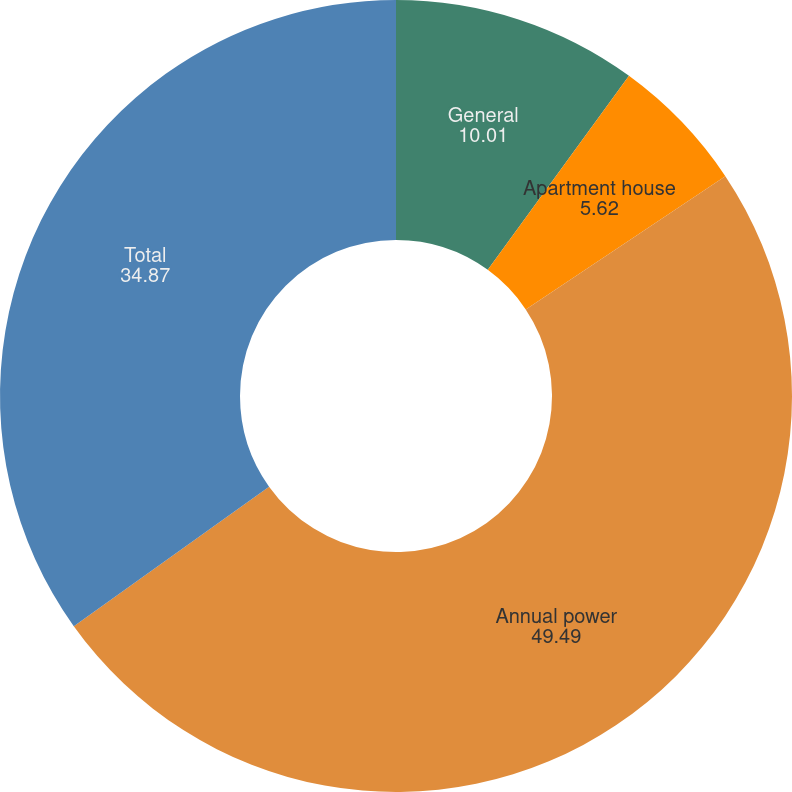Convert chart. <chart><loc_0><loc_0><loc_500><loc_500><pie_chart><fcel>General<fcel>Apartment house<fcel>Annual power<fcel>Total<nl><fcel>10.01%<fcel>5.62%<fcel>49.49%<fcel>34.87%<nl></chart> 